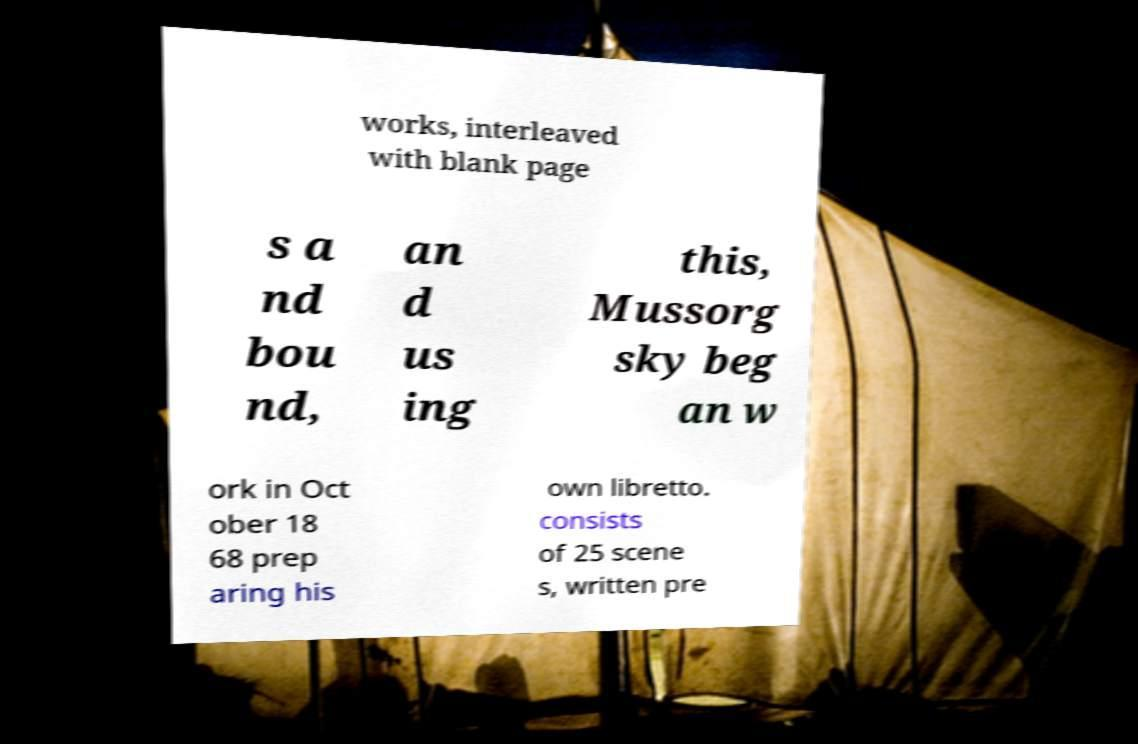What messages or text are displayed in this image? I need them in a readable, typed format. works, interleaved with blank page s a nd bou nd, an d us ing this, Mussorg sky beg an w ork in Oct ober 18 68 prep aring his own libretto. consists of 25 scene s, written pre 